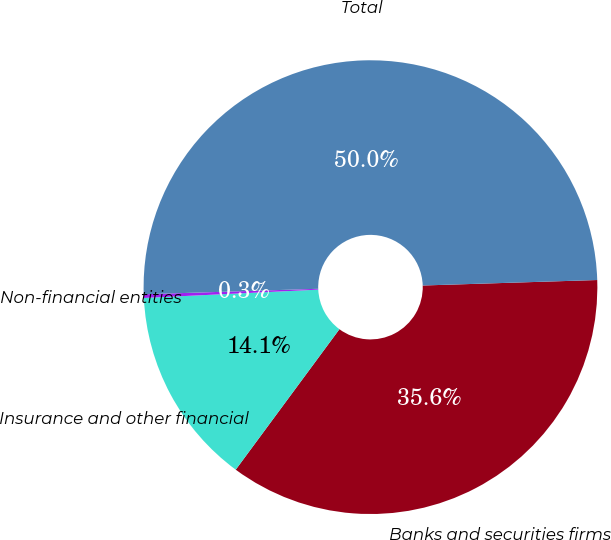Convert chart. <chart><loc_0><loc_0><loc_500><loc_500><pie_chart><fcel>Banks and securities firms<fcel>Insurance and other financial<fcel>Non-financial entities<fcel>Total<nl><fcel>35.62%<fcel>14.12%<fcel>0.26%<fcel>50.0%<nl></chart> 